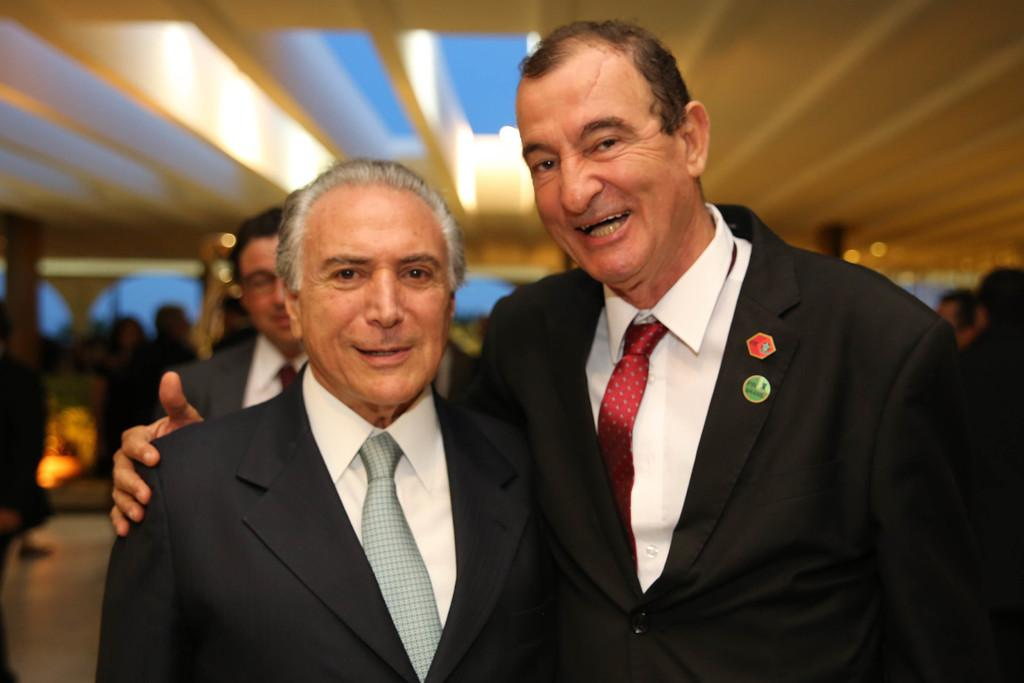How many men are in the image? There are two men in the image. What are the men doing in the image? The men are standing in the image. What type of clothing are the men wearing? The men are wearing suits, ties, and shirts. Can you describe the background of the image? There are people in the background of the image, and a floor is visible. What type of match is being played in the image? There is no match being played in the image; it features two men standing in suits, ties, and shirts. What type of glue is being used to hold the men together in the image? There is no glue present in the image, and the men are standing independently. 